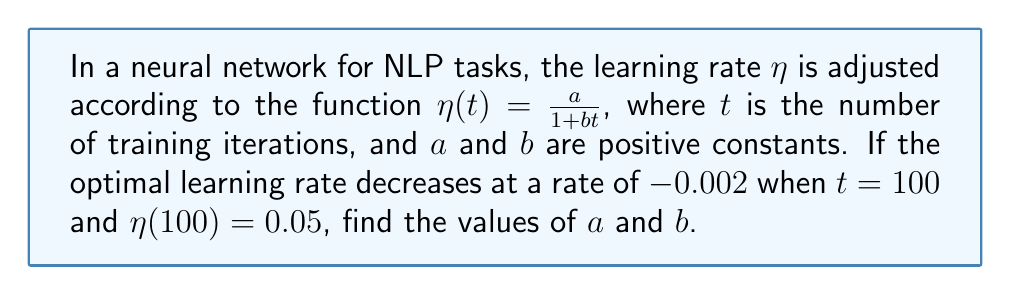Provide a solution to this math problem. Let's approach this step-by-step:

1) We're given that $\eta(t) = \frac{a}{1 + bt}$

2) We know that $\eta(100) = 0.05$, so:

   $0.05 = \frac{a}{1 + 100b}$

3) The rate of change of $\eta$ with respect to $t$ is given by the derivative:

   $$\frac{d\eta}{dt} = -\frac{ab}{(1 + bt)^2}$$

4) We're told that this rate is $-0.002$ when $t = 100$, so:

   $-0.002 = -\frac{ab}{(1 + 100b)^2}$

5) From step 2, we can say that $a = 0.05(1 + 100b)$

6) Substituting this into the equation from step 4:

   $-0.002 = -\frac{0.05b(1 + 100b)}{(1 + 100b)^2} = -\frac{0.05b}{1 + 100b}$

7) Solving this equation:

   $0.002(1 + 100b) = 0.05b$
   $0.002 + 0.2b = 0.05b$
   $0.002 = 0.05b - 0.2b = -0.15b$
   $b = \frac{0.002}{0.15} = \frac{2}{150} = \frac{1}{75}$

8) Now that we know $b$, we can find $a$ using the equation from step 2:

   $a = 0.05(1 + 100(\frac{1}{75})) = 0.05(\frac{175}{75}) = \frac{175}{1500} = \frac{7}{60}$

Therefore, $a = \frac{7}{60}$ and $b = \frac{1}{75}$.
Answer: $a = \frac{7}{60}$, $b = \frac{1}{75}$ 